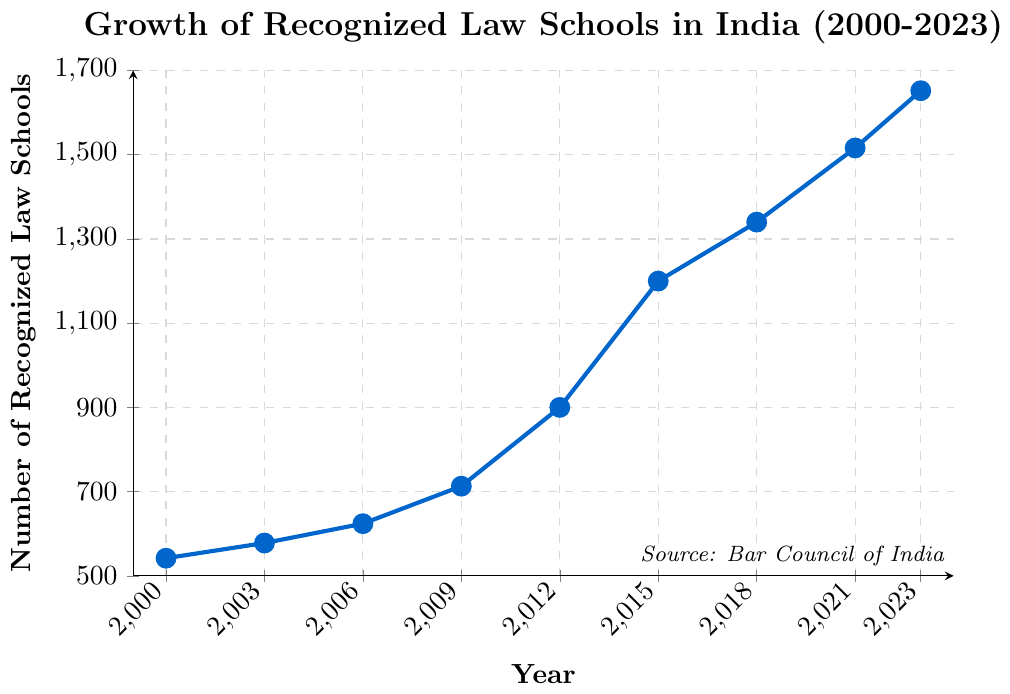What is the total increase in the number of recognized law schools from 2000 to 2023? To find the total increase, subtract the number of recognized law schools in 2000 from the number in 2023. The calculation is 1652 - 542.
Answer: 1110 By how many did the number of recognized law schools increase between 2015 and 2018? To find the increase between these years, subtract the number in 2015 from the number in 2018. The calculation is 1340 - 1200.
Answer: 140 Which year had a greater number of recognized law schools, 2006 or 2009, and by how much? Compare the values for the two years and subtract the smaller from the larger. 2009 had 713 and 2006 had 624. The difference is 713 - 624.
Answer: 2009 by 89 In which period did the number of recognized law schools increase the most: 2000-2003, 2003-2006, or 2009-2012? Calculate the increase for each period: 2000-2003 is 578 - 542 = 36, 2003-2006 is 624 - 578 = 46, and 2009-2012 is 900 - 713 = 187.
Answer: 2009-2012 What is the average number of recognized law schools for the years given in the data? Add all the values and divide by the number of years: (542 + 578 + 624 + 713 + 900 + 1200 + 1340 + 1516 + 1652) / 9. The total sum is 9065, and the average is 9065 / 9.
Answer: 1007.22 In which year did the number of recognized law schools exceed 1000 for the first time? Looking at the data, identify the first year where the number is greater than 1000. 2012 had 900, and 2015 had 1200.
Answer: 2015 How does the growth from 2018 to 2021 compare to the growth from 2021 to 2023? Calculate the growth for each period: 2018 to 2021 is 1516 - 1340 = 176, and 2021 to 2023 is 1652 - 1516 = 136.
Answer: 2018 to 2021 grew by 40 more What is the percentage increase in the number of recognized law schools from 2000 to 2023? Calculate the increase (1652 - 542 = 1110), divide by the 2000 value (542), and multiply by 100. (1110 / 542) × 100.
Answer: 204.80% Which year experienced the highest year-on-year growth in the number of recognized law schools? Compare the growths for each three-year period: 2000-2003, 2003-2006, 2006-2009, 2009-2012, 2012-2015, 2015-2018, 2018-2021, 2021-2023. The highest growth in absolute count is between 2009 and 2012 (187).
Answer: 2009-2012 